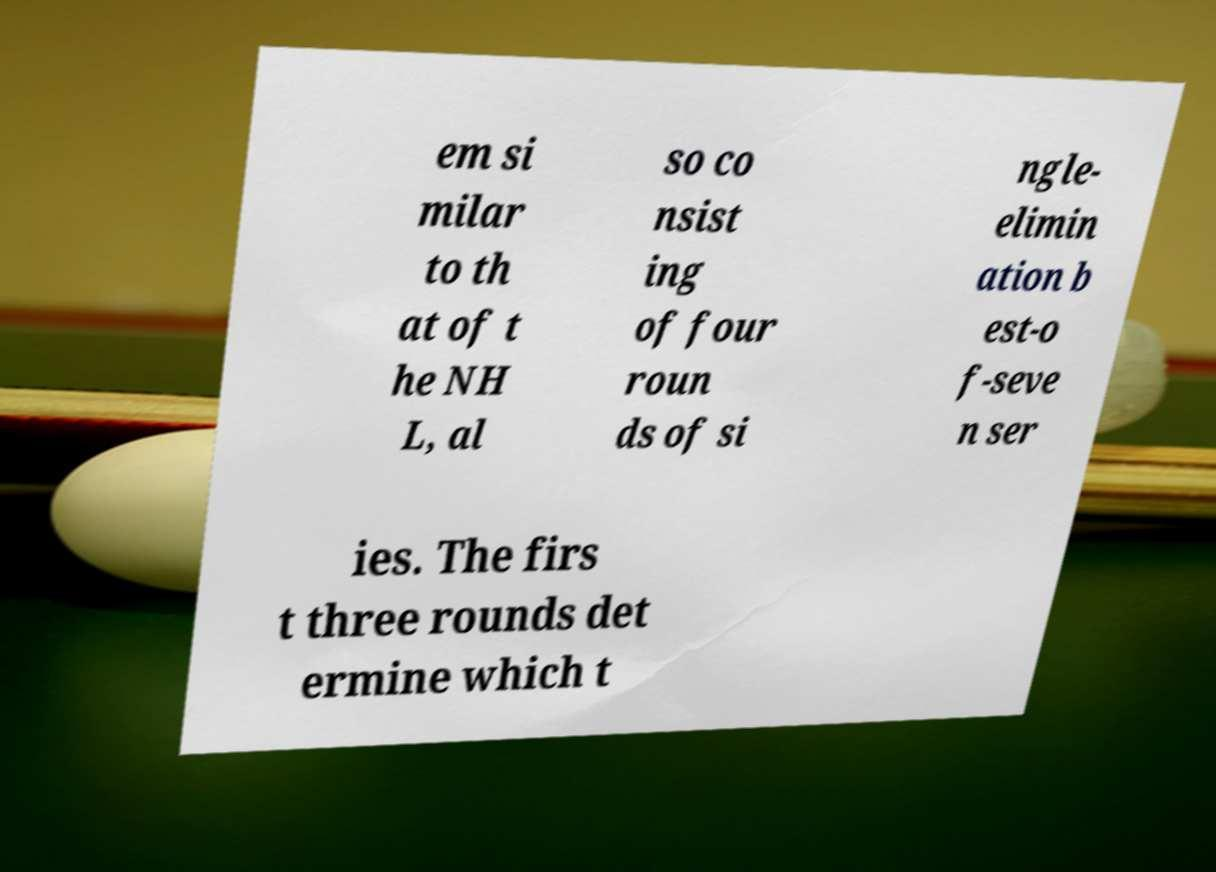Can you accurately transcribe the text from the provided image for me? em si milar to th at of t he NH L, al so co nsist ing of four roun ds of si ngle- elimin ation b est-o f-seve n ser ies. The firs t three rounds det ermine which t 